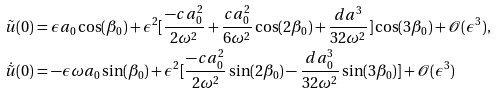Convert formula to latex. <formula><loc_0><loc_0><loc_500><loc_500>& \tilde { u } ( 0 ) = \epsilon a _ { 0 } \cos ( \beta _ { 0 } ) + \epsilon ^ { 2 } [ \frac { - c a _ { 0 } ^ { 2 } } { 2 \omega ^ { 2 } } + \frac { c a _ { 0 } ^ { 2 } } { 6 \omega ^ { 2 } } \cos ( 2 \beta _ { 0 } ) + \frac { d a ^ { 3 } } { 3 2 \omega ^ { 2 } } ] \cos ( 3 \beta _ { 0 } ) + \mathcal { O } ( \epsilon ^ { 3 } ) , \\ & \dot { \tilde { u } } ( 0 ) = - \epsilon \omega a _ { 0 } \sin ( \beta _ { 0 } ) + \epsilon ^ { 2 } [ \frac { - c a _ { 0 } ^ { 2 } } { 2 \omega ^ { 2 } } \sin ( 2 \beta _ { 0 } ) - \frac { d a _ { 0 } ^ { 3 } } { 3 2 \omega ^ { 2 } } \sin ( 3 \beta _ { 0 } ) ] + \mathcal { O } ( \epsilon ^ { 3 } )</formula> 